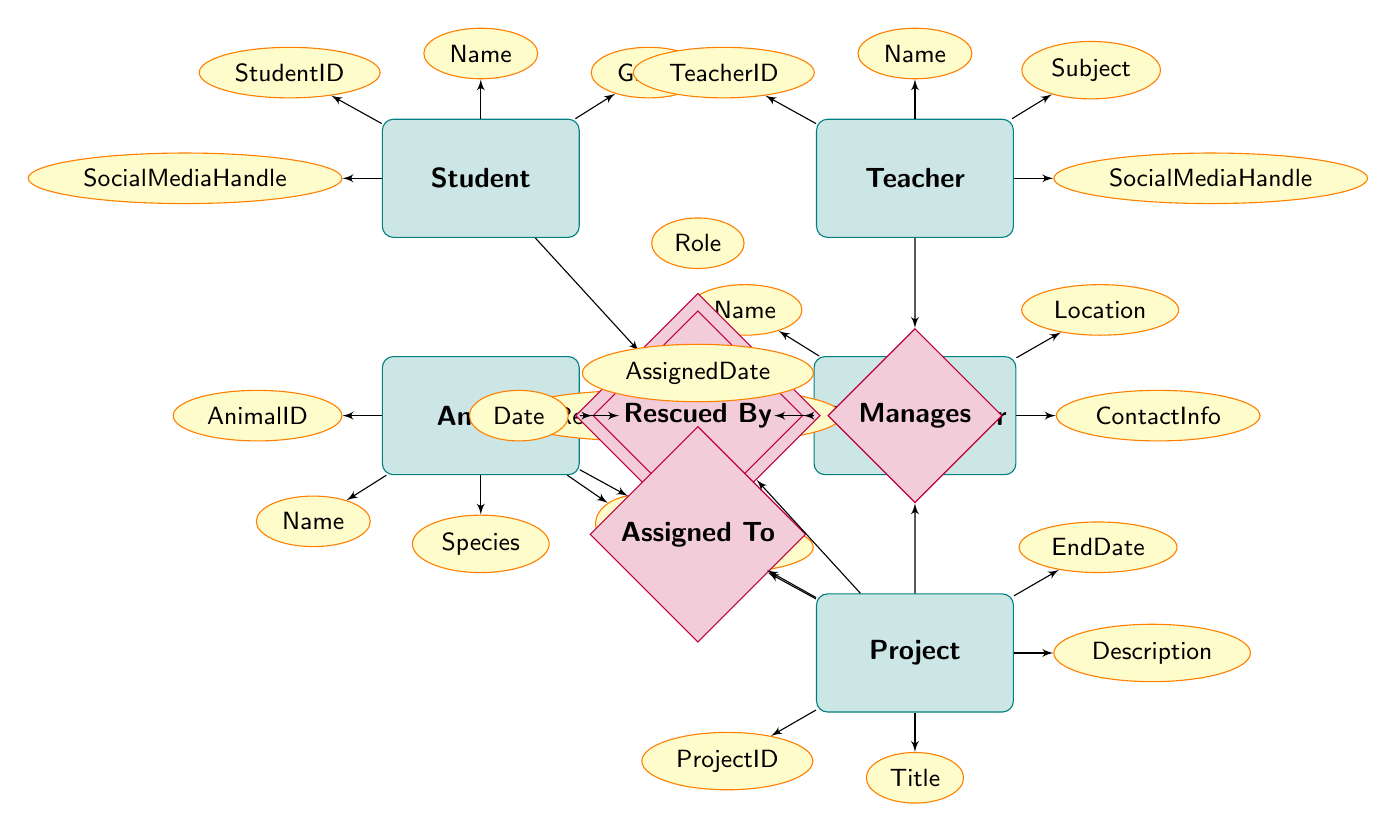What is the primary relationship between a Student and a Project? The diagram illustrates that the primary relationship between a Student and a Project is "Participates In". This is indicated by the relationship diamond labeled "Participates In" connecting the Student and Project entities.
Answer: Participates In How many entities are represented in the diagram? The diagram contains five entities: Student, Teacher, Animal, Rescue Center, and Project. Counting these gives a total of five entities.
Answer: Five What attribute describes the role of a Student in a Project? The attribute that describes the role of a Student in a Project is "Role". This is linked to the relationship "Participates In" between Students and Projects.
Answer: Role Which entity has an attribute called SocialMediaHandle? Both the Student and Teacher entities have an attribute called "SocialMediaHandle", with each entity's attributes clearly listed near them in the diagram.
Answer: Student, Teacher Which relationship connects the Animal and Rescue Center entities? The relationship that connects the Animal and Rescue Center entities is "Rescued By". This is shown in the diagram with the diamond labeled "Rescued By" pointing to both entities.
Answer: Rescued By What is the relationship between Teacher and Project? In the diagram, the relationship between Teacher and Project is “Manages”; this is represented by the diamond labeled "Manages" connecting these two entities directly in the diagram.
Answer: Manages What is the AssignedDate attribute associated with? The AssignedDate attribute is associated with the relationship "Assigned To", which connects the Animal and Project entities. It defines the date an animal is assigned to a specific project.
Answer: Assigned To How many attributes does the Animal entity have? The Animal entity has five attributes: AnimalID, Name, Species, Age, and HealthStatus. Counting these gives a total of five attributes for the Animal entity.
Answer: Five What does the Rescue Center's attribute "ContactInfo" refer to? The "ContactInfo" attribute of the Rescue Center entity refers to the communication details for the rescue center, which assists in coordinating animal rescue efforts.
Answer: ContactInfo 